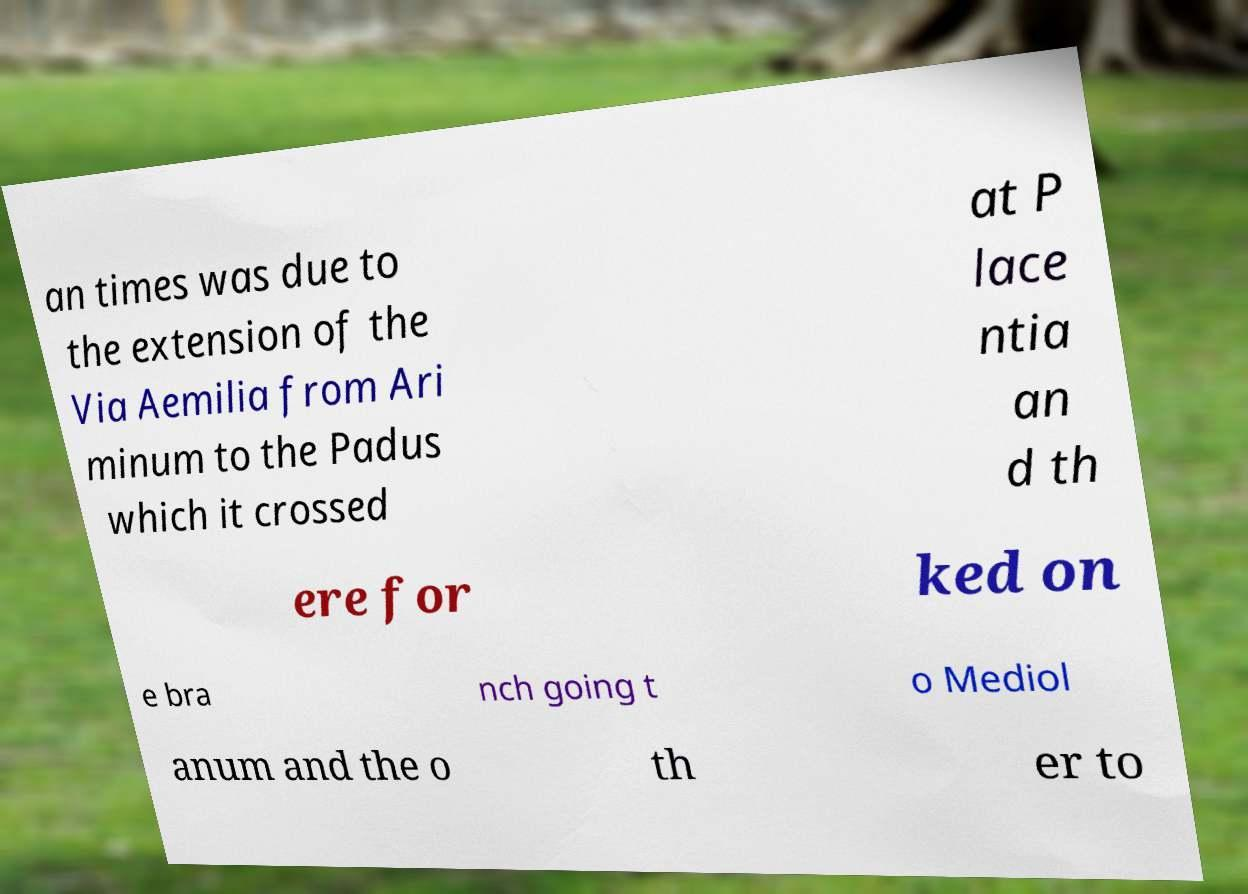Can you accurately transcribe the text from the provided image for me? an times was due to the extension of the Via Aemilia from Ari minum to the Padus which it crossed at P lace ntia an d th ere for ked on e bra nch going t o Mediol anum and the o th er to 